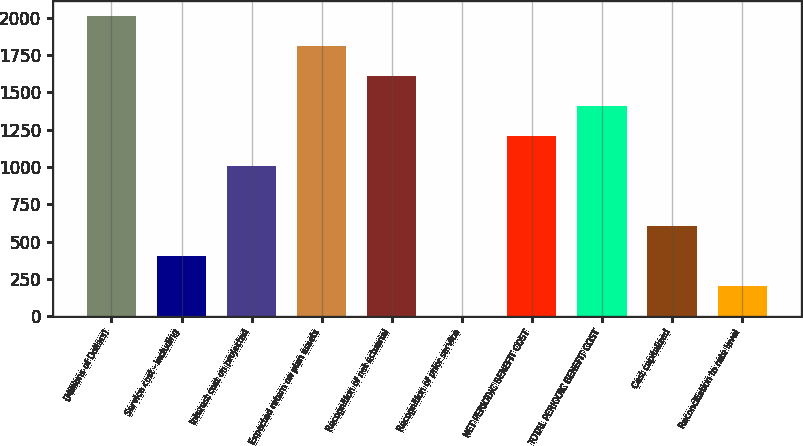Convert chart. <chart><loc_0><loc_0><loc_500><loc_500><bar_chart><fcel>(Millions of Dollars)<fcel>Service cost - including<fcel>Interest cost on projected<fcel>Expected return on plan assets<fcel>Recognition of net actuarial<fcel>Recognition of prior service<fcel>NET PERIODIC BENEFIT COST<fcel>TOTAL PERIODIC BENEFIT COST<fcel>Cost capitalized<fcel>Reconciliation to rate level<nl><fcel>2014<fcel>404.4<fcel>1008<fcel>1812.8<fcel>1611.6<fcel>2<fcel>1209.2<fcel>1410.4<fcel>605.6<fcel>203.2<nl></chart> 